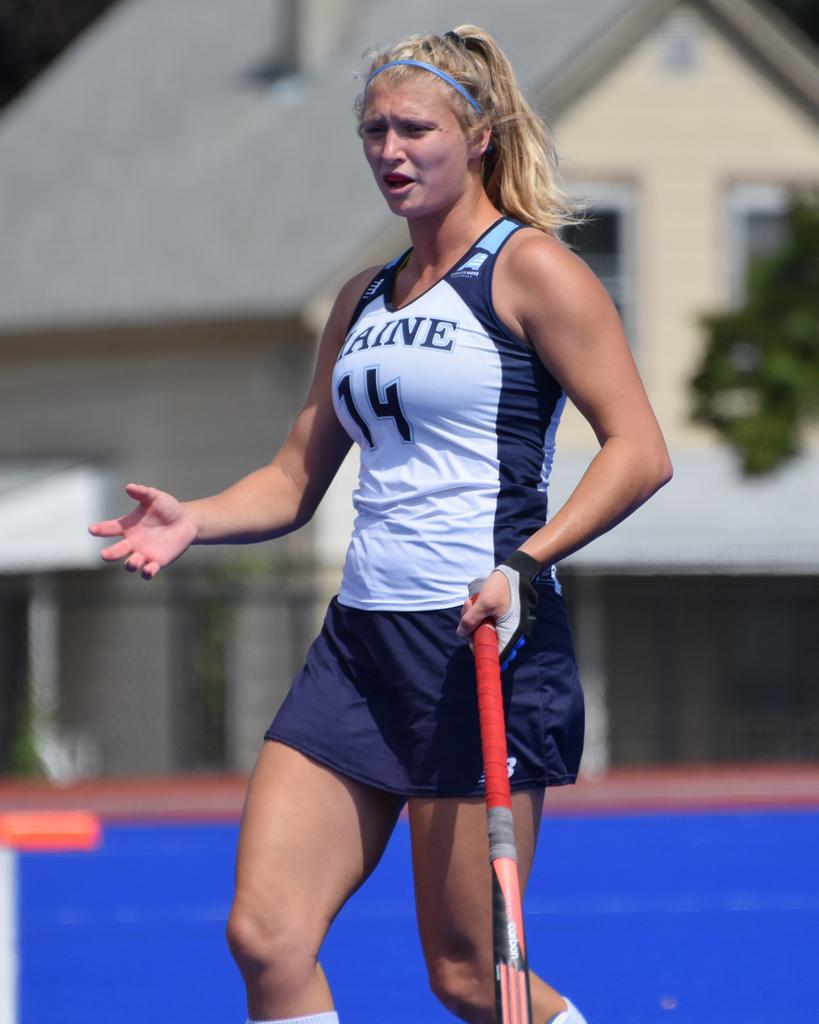<image>
Describe the image concisely. A softball player wearing a tank top with number 14 on the front is holding a bat. 